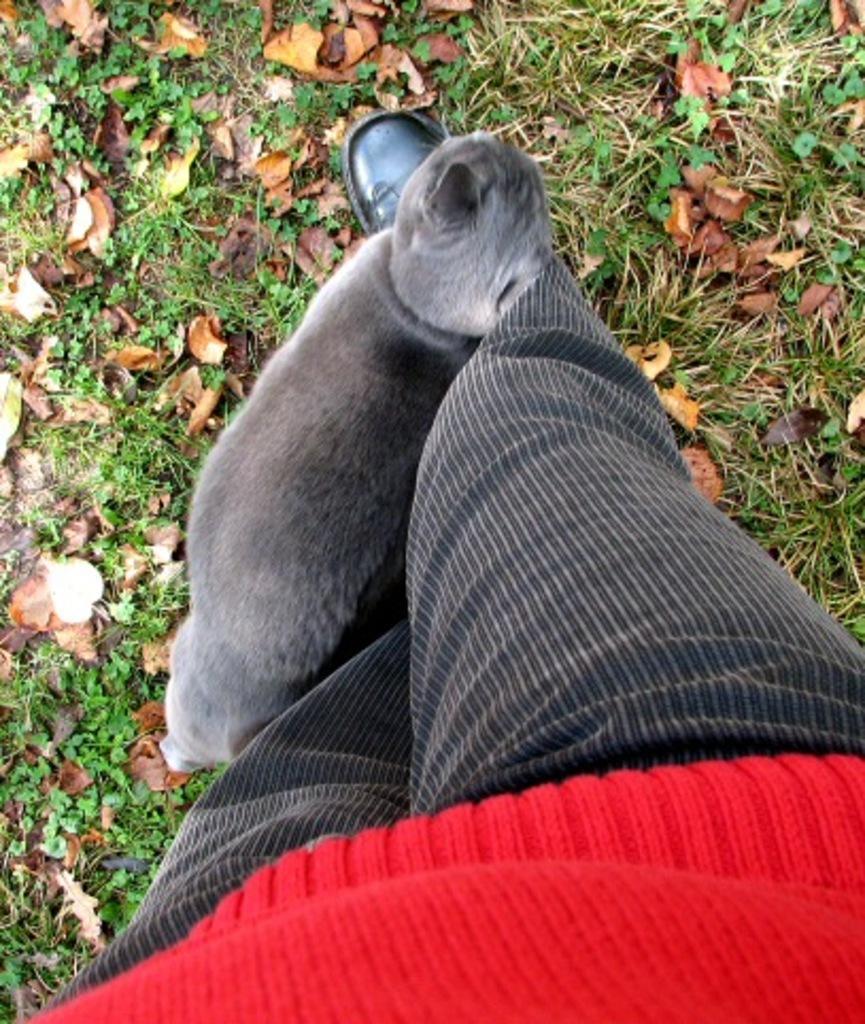How would you summarize this image in a sentence or two? As we can see in the image there is a ash colour cat who is standing closer to a person who is wearing red shirt and black and white striped pant and they both are standing on the ground which is covered with grass and dry leaves. 